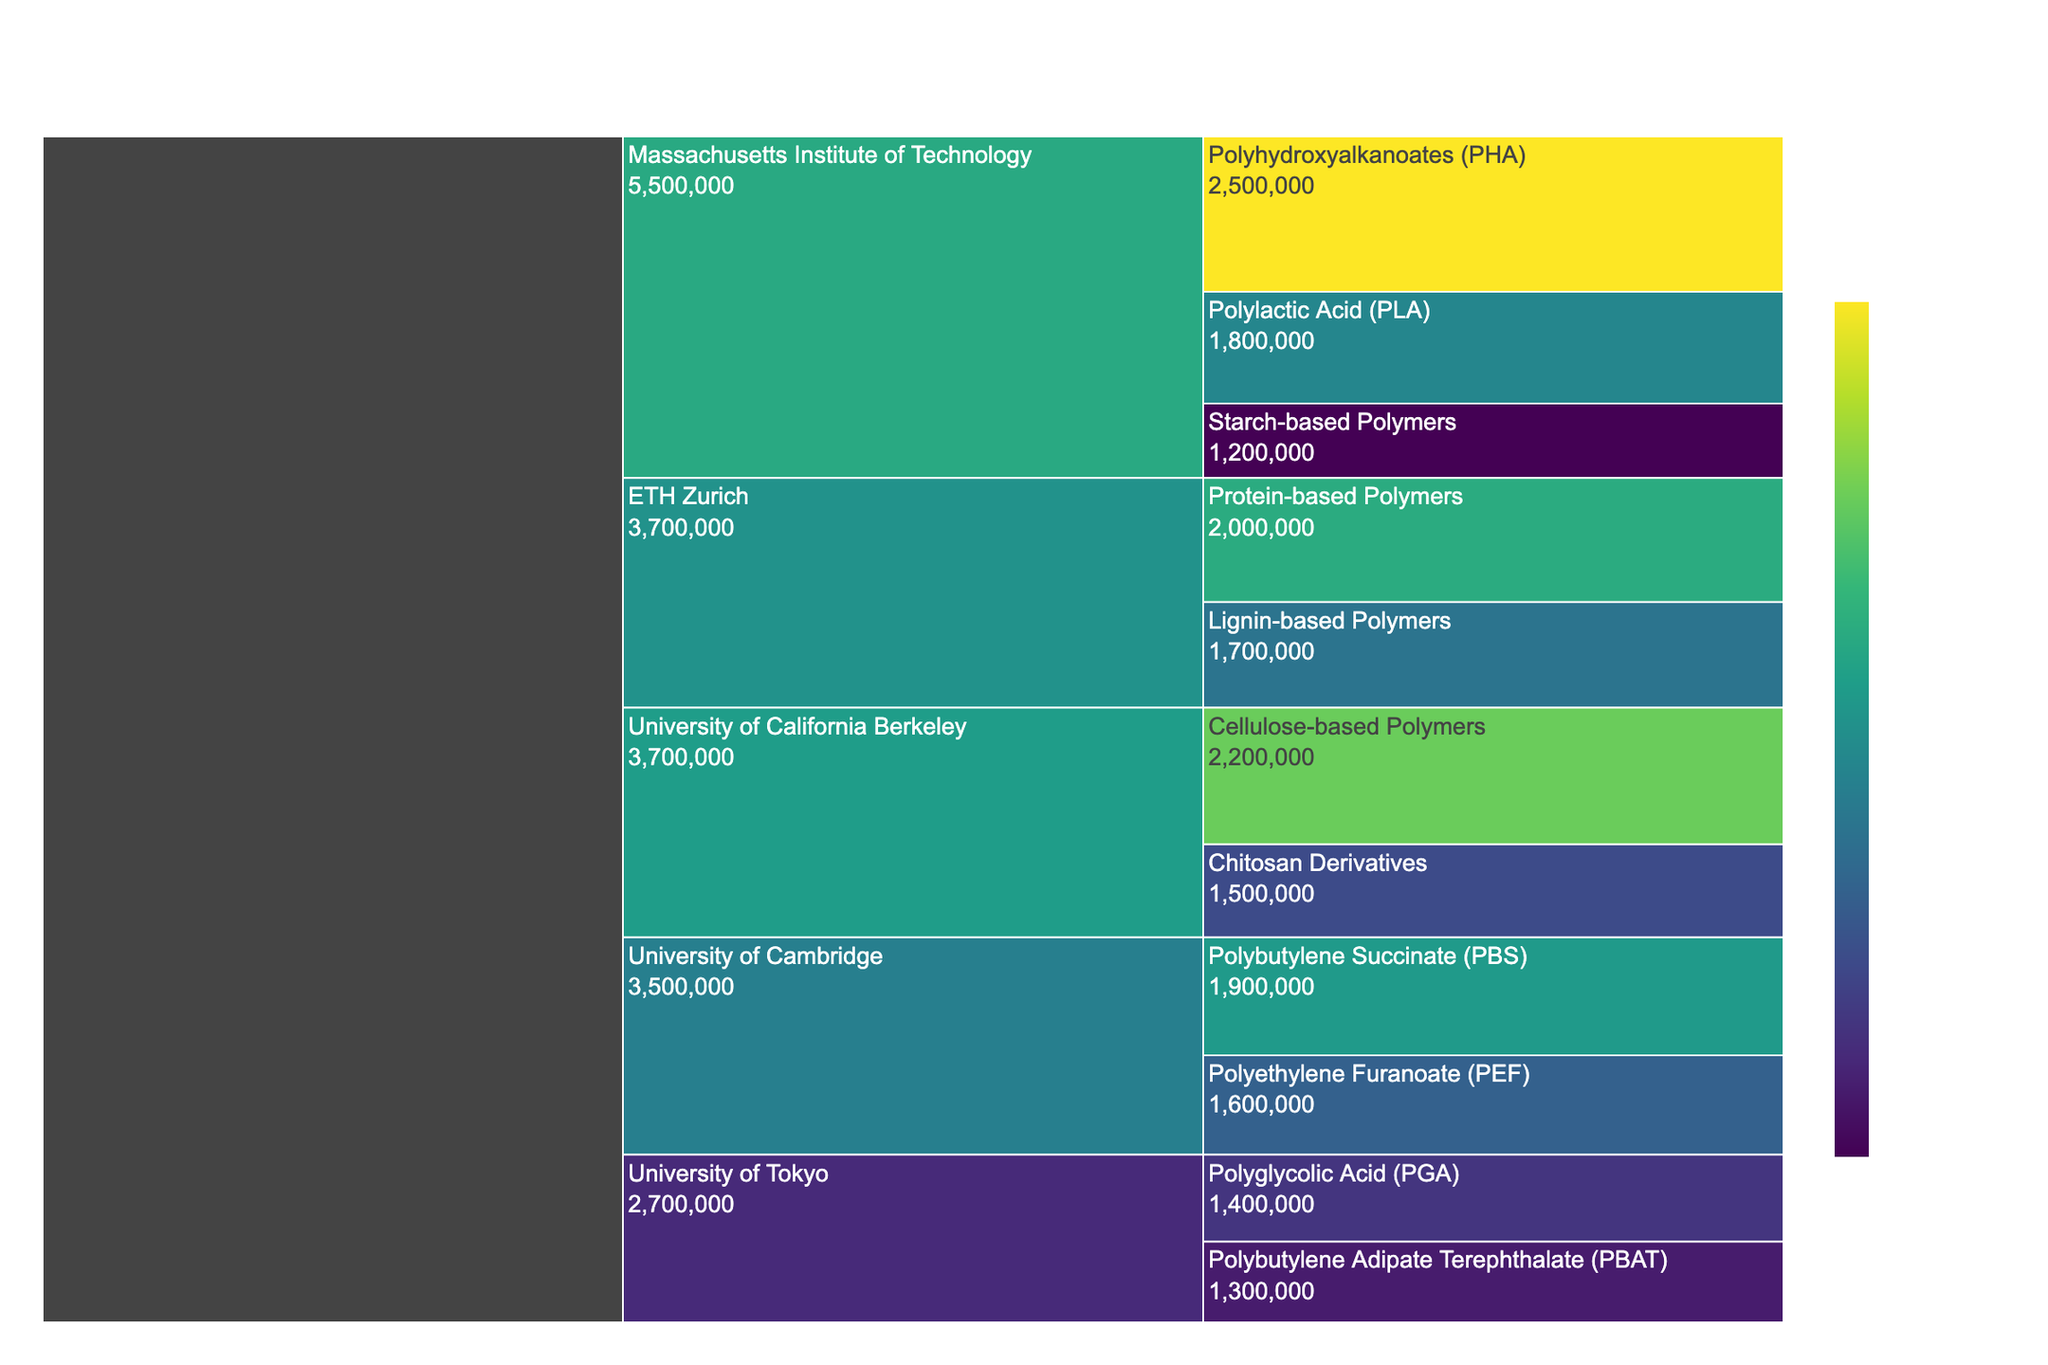How much funding did the Massachusetts Institute of Technology receive in total? Sum the funding amounts for all projects at the Massachusetts Institute of Technology: PHA ($2,500,000) + PLA ($1,800,000) + Starch-based Polymers ($1,200,000). The total is $2,500,000 + $1,800,000 + $1,200,000 = $5,500,000.
Answer: $5,500,000 Which research institution received the highest funding for individual projects? Compare the individual funding amounts for each project across all institutions. The highest funding amount is for the PHA project at the Massachusetts Institute of Technology with $2,500,000.
Answer: Massachusetts Institute of Technology What is the difference in funding between the Cellulose-based Polymers project at the University of California Berkeley and the Polyglycolic Acid (PGA) project at the University of Tokyo? Subtract the funding for the PGA project at the University of Tokyo ($1,400,000) from the funding for the Cellulose-based Polymers project at the University of California Berkeley ($2,200,000). The difference is $2,200,000 - $1,400,000 = $800,000.
Answer: $800,000 What is the combined funding for all projects focused on starch-based and cellulose-based polymers? Add the funding amounts for Starch-based Polymers at MIT ($1,200,000) and Cellulose-based Polymers at the University of California Berkeley ($2,200,000). The combined funding is $1,200,000 + $2,200,000 = $3,400,000.
Answer: $3,400,000 Which project focus has the lowest funding at the University of Tokyo? Compare the funding for the two projects at the University of Tokyo: PGA ($1,400,000) and PBAT ($1,300,000). The lower funding amount is for PBAT with $1,300,000.
Answer: Polybutylene Adipate Terephthalate (PBAT) How does the funding of Polyhydroxyalkanoates (PHA) at the Massachusetts Institute of Technology compare to the funding of Protein-based Polymers at ETH Zurich? Compare the funding amounts directly: PHA at MIT ($2,500,000) and Protein-based Polymers at ETH Zurich ($2,000,000). PHA has $500,000 more funding.
Answer: PHA at MIT has $500,000 more funding What is the total amount of funding allocated to biodegradable polymer studies across all institutions? Sum the funding amounts for all projects across all institutions: $2,500,000 + $1,800,000 + $1,200,000 + $2,200,000 + $1,500,000 + $1,900,000 + $1,600,000 + $2,000,000 + $1,700,000 + $1,400,000 + $1,300,000. The total is $18,100,000.
Answer: $18,100,000 Which institution has the most diverse range of funded projects, and how can you tell? Examine the number of different project focuses per institution. Massachusetts Institute of Technology has three different projects: PHA, PLA, and Starch-based Polymers, which is more than any other institution.
Answer: Massachusetts Institute of Technology What is the average funding per project for the University of Cambridge? Sum the funding for all projects at the University of Cambridge and divide by the number of projects: ($1,900,000 + $1,600,000) / 2. The total is $3,500,000; thus, the average is $3,500,000 / 2 = $1,750,000.
Answer: $1,750,000 Is the funding for Polyethylene Furanoate (PEF) at the University of Cambridge closer to Protein-based Polymers or Lignin-based Polymers at ETH Zurich? Compare the funding for PEF ($1,600,000) at the University of Cambridge to Protein-based Polymers ($2,000,000) and Lignin-based Polymers ($1,700,000) at ETH Zurich. The difference between PEF and Protein-based Polymers is $400,000; the difference between PEF and Lignin-based Polymers is $100,000. PEF is closer to Lignin-based Polymers.
Answer: Lignin-based Polymers at ETH Zurich 